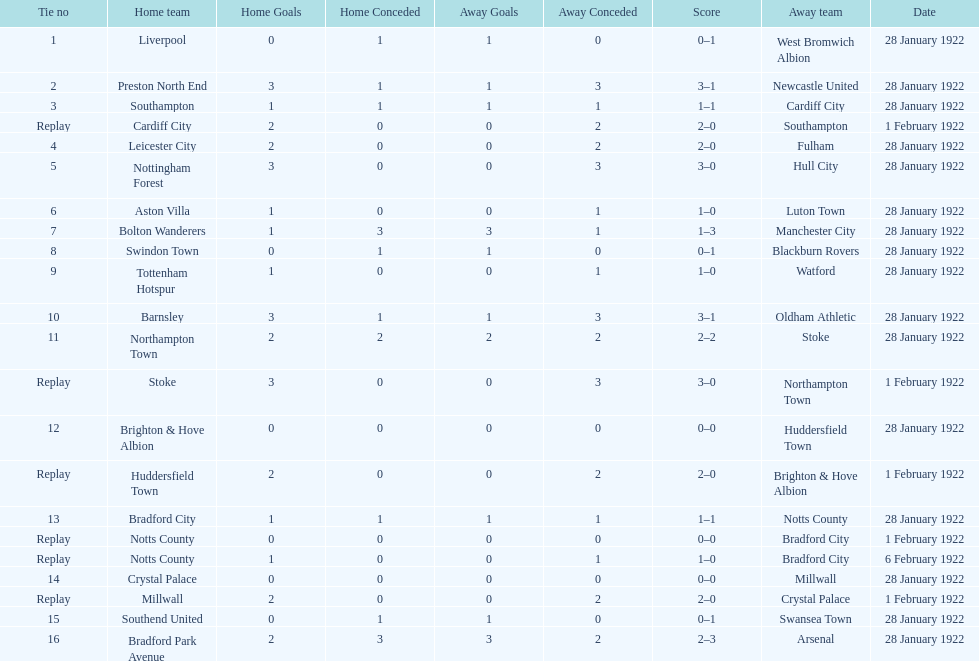Could you help me parse every detail presented in this table? {'header': ['Tie no', 'Home team', 'Home Goals', 'Home Conceded', 'Away Goals', 'Away Conceded', 'Score', 'Away team', 'Date'], 'rows': [['1', 'Liverpool', '0', '1', '1', '0', '0–1', 'West Bromwich Albion', '28 January 1922'], ['2', 'Preston North End', '3', '1', '1', '3', '3–1', 'Newcastle United', '28 January 1922'], ['3', 'Southampton', '1', '1', '1', '1', '1–1', 'Cardiff City', '28 January 1922'], ['Replay', 'Cardiff City', '2', '0', '0', '2', '2–0', 'Southampton', '1 February 1922'], ['4', 'Leicester City', '2', '0', '0', '2', '2–0', 'Fulham', '28 January 1922'], ['5', 'Nottingham Forest', '3', '0', '0', '3', '3–0', 'Hull City', '28 January 1922'], ['6', 'Aston Villa', '1', '0', '0', '1', '1–0', 'Luton Town', '28 January 1922'], ['7', 'Bolton Wanderers', '1', '3', '3', '1', '1–3', 'Manchester City', '28 January 1922'], ['8', 'Swindon Town', '0', '1', '1', '0', '0–1', 'Blackburn Rovers', '28 January 1922'], ['9', 'Tottenham Hotspur', '1', '0', '0', '1', '1–0', 'Watford', '28 January 1922'], ['10', 'Barnsley', '3', '1', '1', '3', '3–1', 'Oldham Athletic', '28 January 1922'], ['11', 'Northampton Town', '2', '2', '2', '2', '2–2', 'Stoke', '28 January 1922'], ['Replay', 'Stoke', '3', '0', '0', '3', '3–0', 'Northampton Town', '1 February 1922'], ['12', 'Brighton & Hove Albion', '0', '0', '0', '0', '0–0', 'Huddersfield Town', '28 January 1922'], ['Replay', 'Huddersfield Town', '2', '0', '0', '2', '2–0', 'Brighton & Hove Albion', '1 February 1922'], ['13', 'Bradford City', '1', '1', '1', '1', '1–1', 'Notts County', '28 January 1922'], ['Replay', 'Notts County', '0', '0', '0', '0', '0–0', 'Bradford City', '1 February 1922'], ['Replay', 'Notts County', '1', '0', '0', '1', '1–0', 'Bradford City', '6 February 1922'], ['14', 'Crystal Palace', '0', '0', '0', '0', '0–0', 'Millwall', '28 January 1922'], ['Replay', 'Millwall', '2', '0', '0', '2', '2–0', 'Crystal Palace', '1 February 1922'], ['15', 'Southend United', '0', '1', '1', '0', '0–1', 'Swansea Town', '28 January 1922'], ['16', 'Bradford Park Avenue', '2', '3', '3', '2', '2–3', 'Arsenal', '28 January 1922']]} What is the number of points scored on 6 february 1922? 1. 